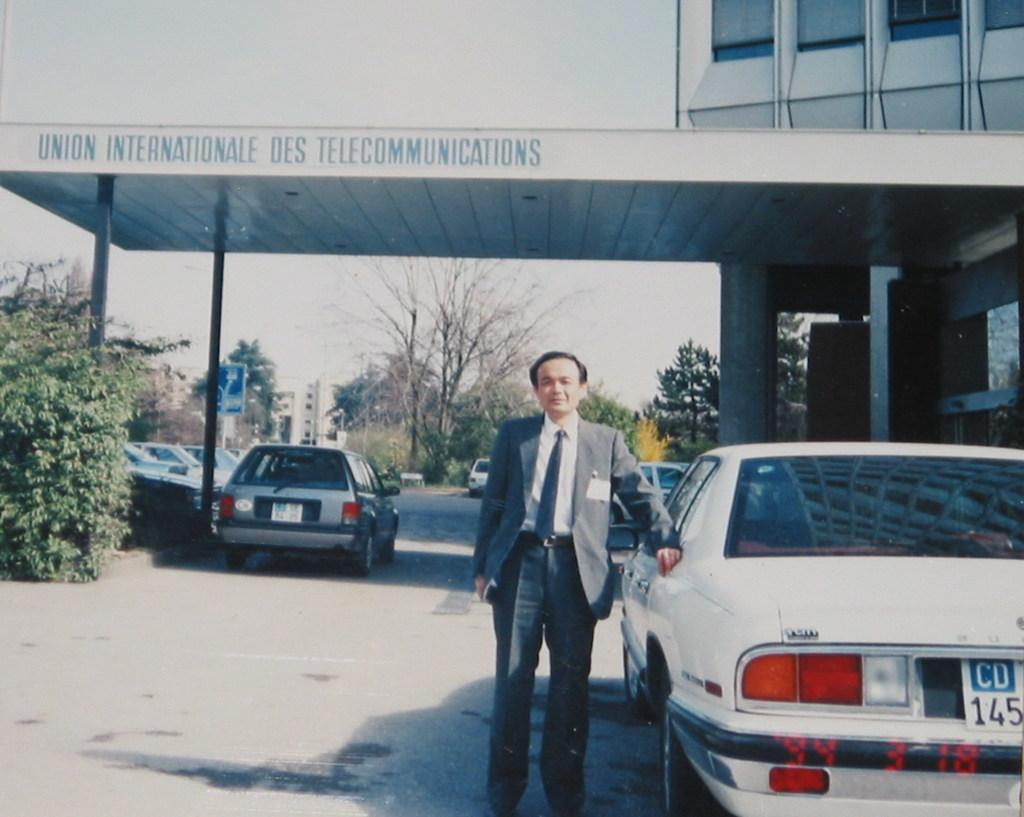What type of structure is present in the image? There is a building in the image. What else can be seen in the image besides the building? There is text visible in the image, as well as trees, another building in the background, cars parked, a man standing, and the sky. How many cows are grazing in the image? There are no cows present in the image. What type of history is depicted in the text visible in the image? The provided facts do not mention any specific history or text content, so it cannot be determined from the image. 